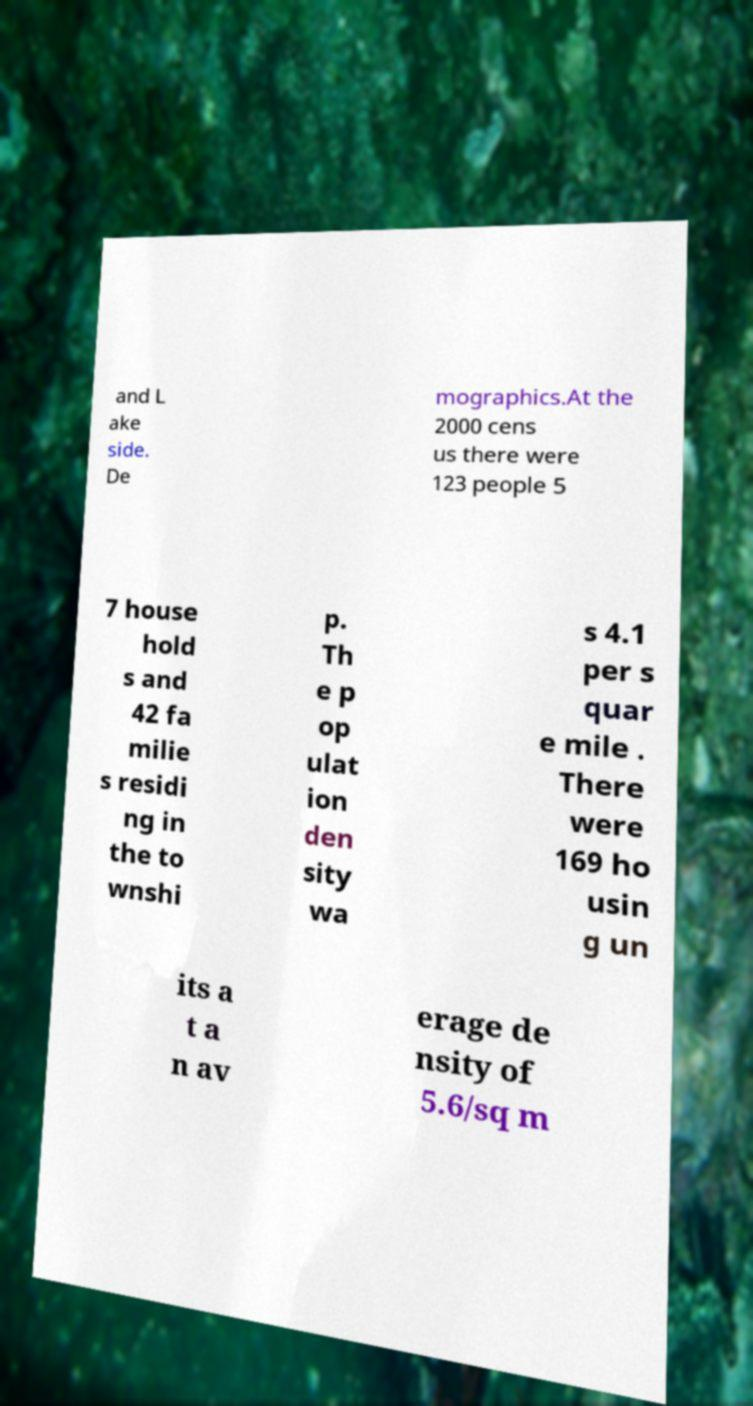What messages or text are displayed in this image? I need them in a readable, typed format. and L ake side. De mographics.At the 2000 cens us there were 123 people 5 7 house hold s and 42 fa milie s residi ng in the to wnshi p. Th e p op ulat ion den sity wa s 4.1 per s quar e mile . There were 169 ho usin g un its a t a n av erage de nsity of 5.6/sq m 